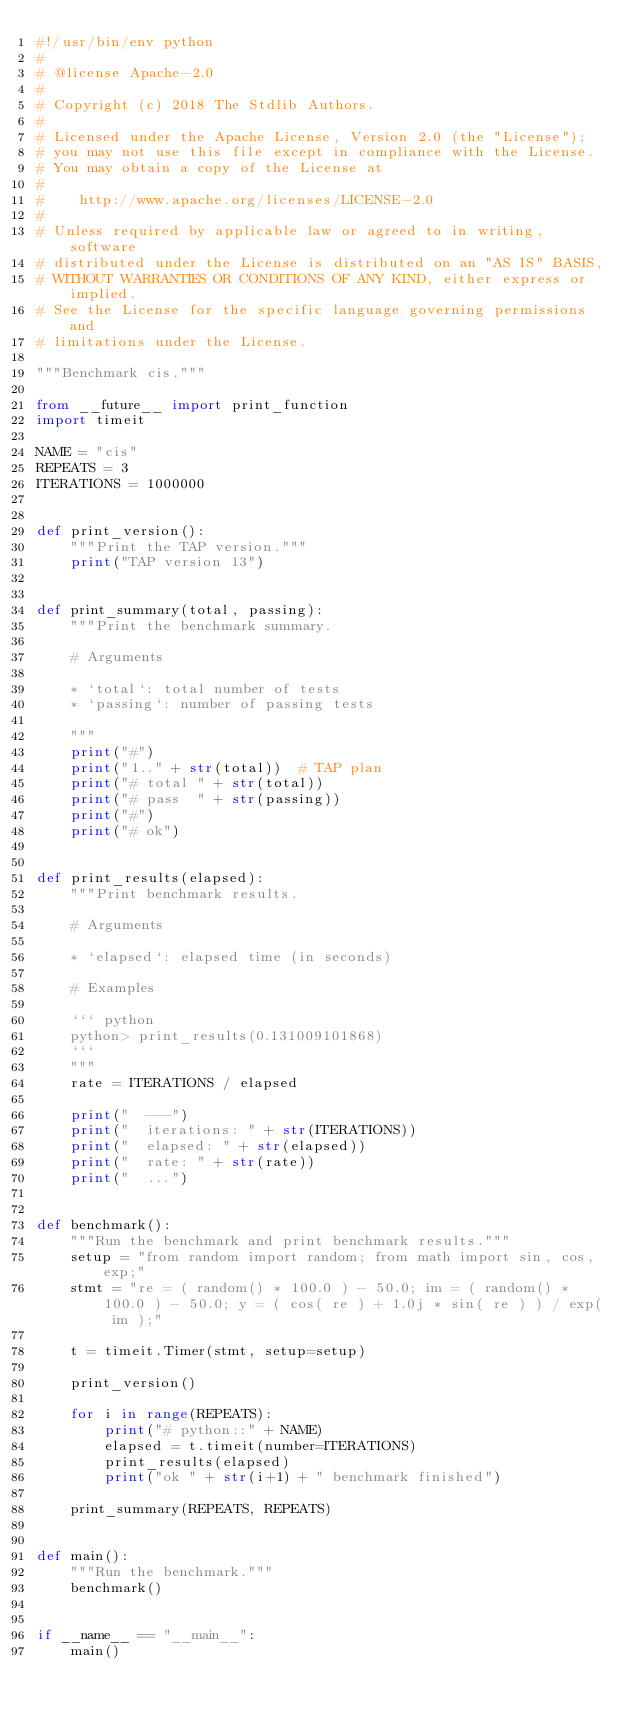<code> <loc_0><loc_0><loc_500><loc_500><_Python_>#!/usr/bin/env python
#
# @license Apache-2.0
#
# Copyright (c) 2018 The Stdlib Authors.
#
# Licensed under the Apache License, Version 2.0 (the "License");
# you may not use this file except in compliance with the License.
# You may obtain a copy of the License at
#
#    http://www.apache.org/licenses/LICENSE-2.0
#
# Unless required by applicable law or agreed to in writing, software
# distributed under the License is distributed on an "AS IS" BASIS,
# WITHOUT WARRANTIES OR CONDITIONS OF ANY KIND, either express or implied.
# See the License for the specific language governing permissions and
# limitations under the License.

"""Benchmark cis."""

from __future__ import print_function
import timeit

NAME = "cis"
REPEATS = 3
ITERATIONS = 1000000


def print_version():
    """Print the TAP version."""
    print("TAP version 13")


def print_summary(total, passing):
    """Print the benchmark summary.

    # Arguments

    * `total`: total number of tests
    * `passing`: number of passing tests

    """
    print("#")
    print("1.." + str(total))  # TAP plan
    print("# total " + str(total))
    print("# pass  " + str(passing))
    print("#")
    print("# ok")


def print_results(elapsed):
    """Print benchmark results.

    # Arguments

    * `elapsed`: elapsed time (in seconds)

    # Examples

    ``` python
    python> print_results(0.131009101868)
    ```
    """
    rate = ITERATIONS / elapsed

    print("  ---")
    print("  iterations: " + str(ITERATIONS))
    print("  elapsed: " + str(elapsed))
    print("  rate: " + str(rate))
    print("  ...")


def benchmark():
    """Run the benchmark and print benchmark results."""
    setup = "from random import random; from math import sin, cos, exp;"
    stmt = "re = ( random() * 100.0 ) - 50.0; im = ( random() * 100.0 ) - 50.0; y = ( cos( re ) + 1.0j * sin( re ) ) / exp( im );"

    t = timeit.Timer(stmt, setup=setup)

    print_version()

    for i in range(REPEATS):
        print("# python::" + NAME)
        elapsed = t.timeit(number=ITERATIONS)
        print_results(elapsed)
        print("ok " + str(i+1) + " benchmark finished")

    print_summary(REPEATS, REPEATS)


def main():
    """Run the benchmark."""
    benchmark()


if __name__ == "__main__":
    main()
</code> 